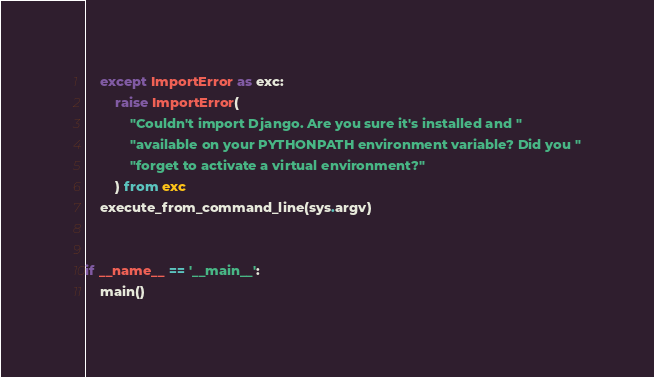<code> <loc_0><loc_0><loc_500><loc_500><_Python_>    except ImportError as exc:
        raise ImportError(
            "Couldn't import Django. Are you sure it's installed and "
            "available on your PYTHONPATH environment variable? Did you "
            "forget to activate a virtual environment?"
        ) from exc
    execute_from_command_line(sys.argv)


if __name__ == '__main__':
    main()
</code> 